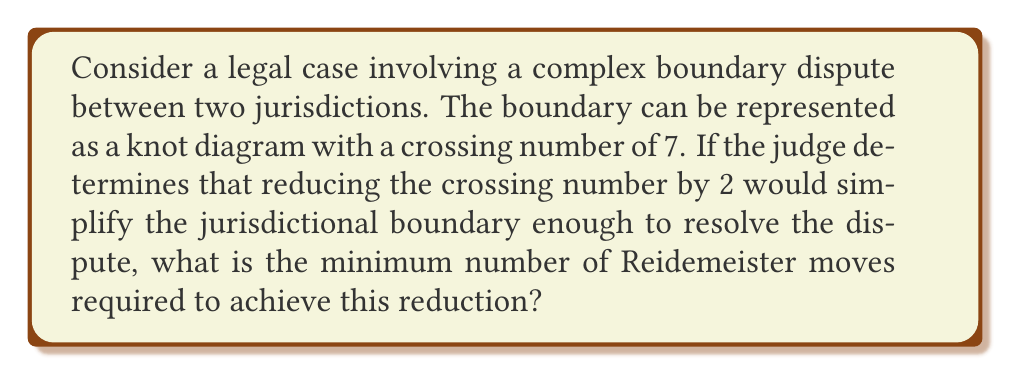Help me with this question. To approach this problem, we need to consider the following steps:

1. Understand the given information:
   - The initial knot diagram has a crossing number of 7.
   - The goal is to reduce the crossing number by 2, resulting in a crossing number of 5.

2. Recall the Reidemeister moves:
   - Type I: Twist or untwist a strand
   - Type II: Move one strand completely over or under another
   - Type III: Move a strand over or under a crossing

3. Consider the effect of each Reidemeister move on the crossing number:
   - Type I can decrease or increase the crossing number by 1.
   - Type II can decrease the crossing number by 2.
   - Type III does not change the crossing number.

4. Analyze the minimum number of moves required:
   - Since we need to reduce the crossing number by 2, a single Type II move could potentially achieve this.
   - However, it's not always possible to perform a Type II move directly on a given knot diagram.
   - In the worst case, we might need to use Type I or Type III moves to prepare the knot for a Type II move.

5. Determine the minimum number of moves:
   - Best case: One Type II move (if the knot configuration allows)
   - Worst case: Two Type I moves (one to create an additional crossing and one to remove it along with an existing crossing)

Therefore, the minimum number of Reidemeister moves required is 1, which would be a single Type II move if the knot configuration allows for it.
Answer: 1 